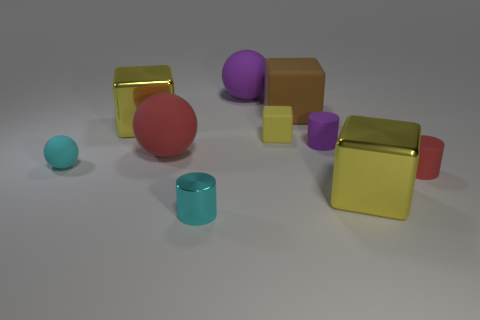What material do the reflective objects in the image most likely represent? The highly reflective objects appear to represent materials such as polished metal or plastic due to their shiny surfaces and crisp edges. 